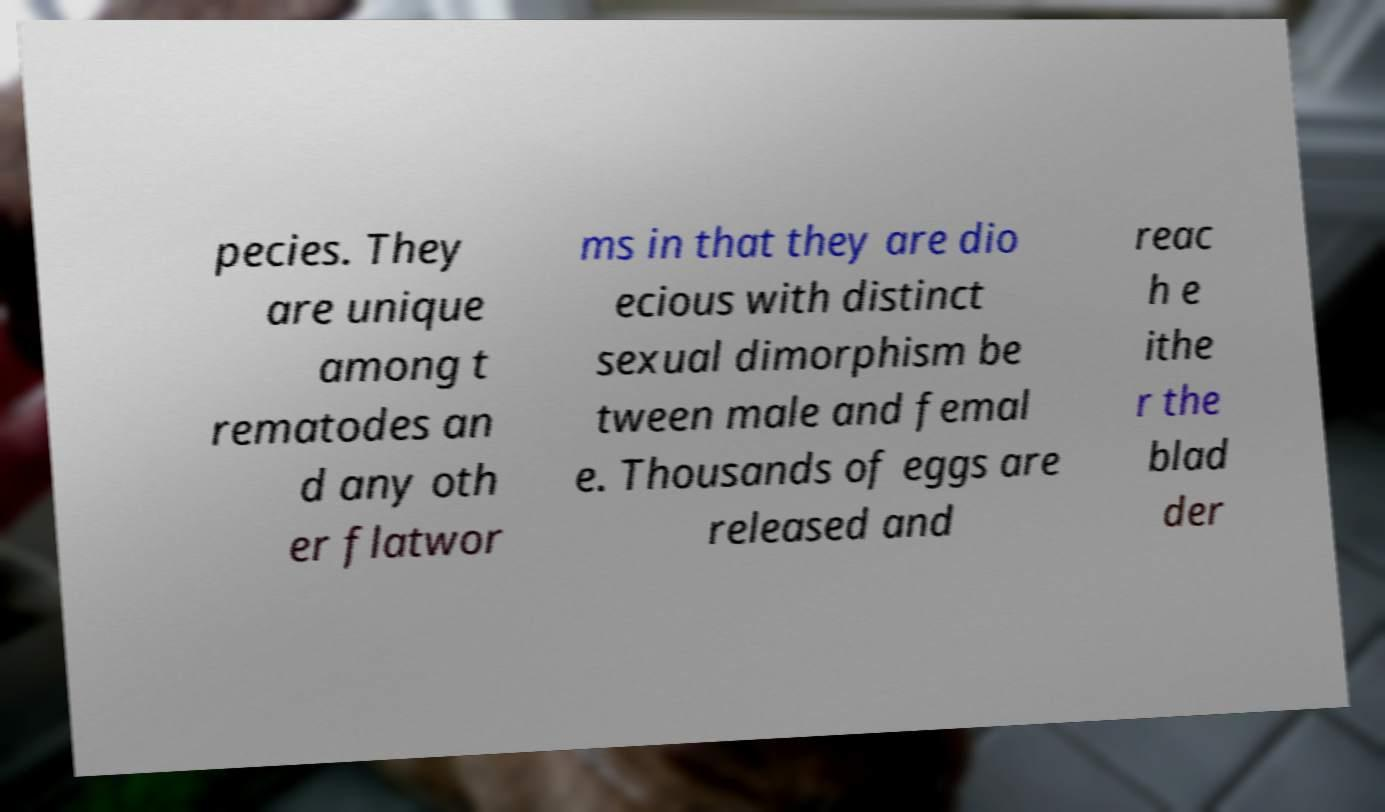For documentation purposes, I need the text within this image transcribed. Could you provide that? pecies. They are unique among t rematodes an d any oth er flatwor ms in that they are dio ecious with distinct sexual dimorphism be tween male and femal e. Thousands of eggs are released and reac h e ithe r the blad der 